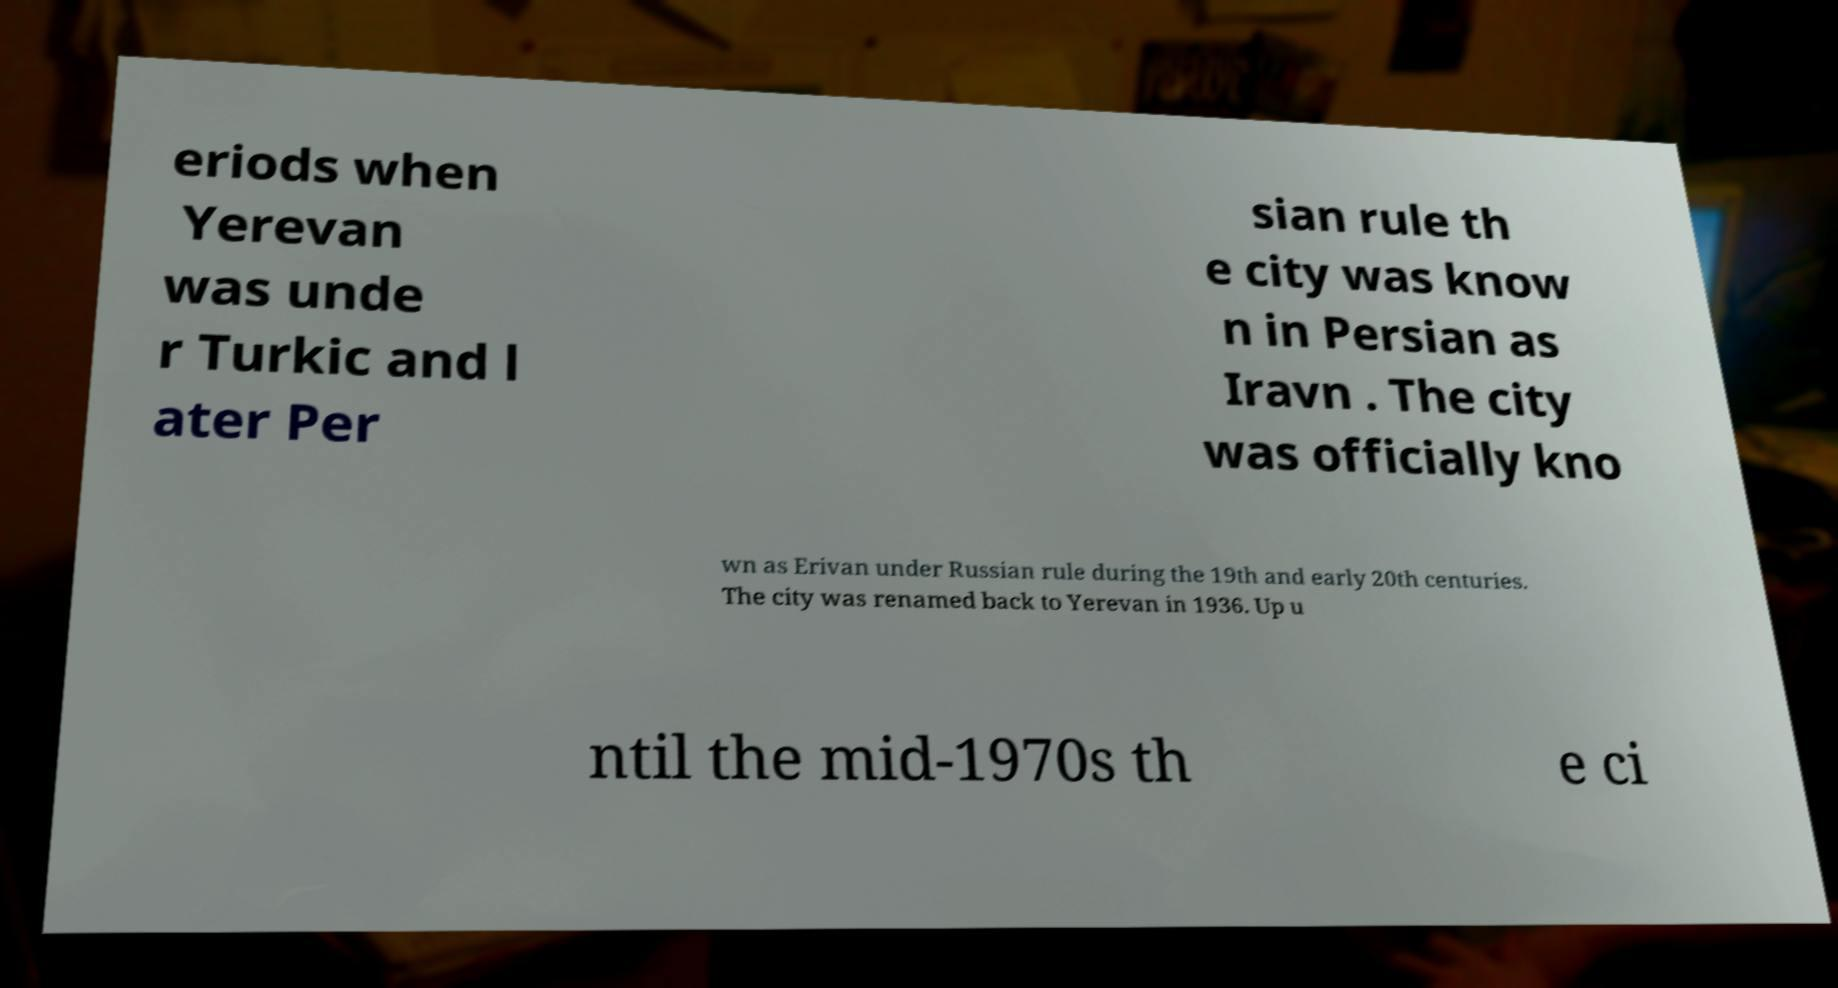Could you extract and type out the text from this image? eriods when Yerevan was unde r Turkic and l ater Per sian rule th e city was know n in Persian as Iravn . The city was officially kno wn as Erivan under Russian rule during the 19th and early 20th centuries. The city was renamed back to Yerevan in 1936. Up u ntil the mid-1970s th e ci 